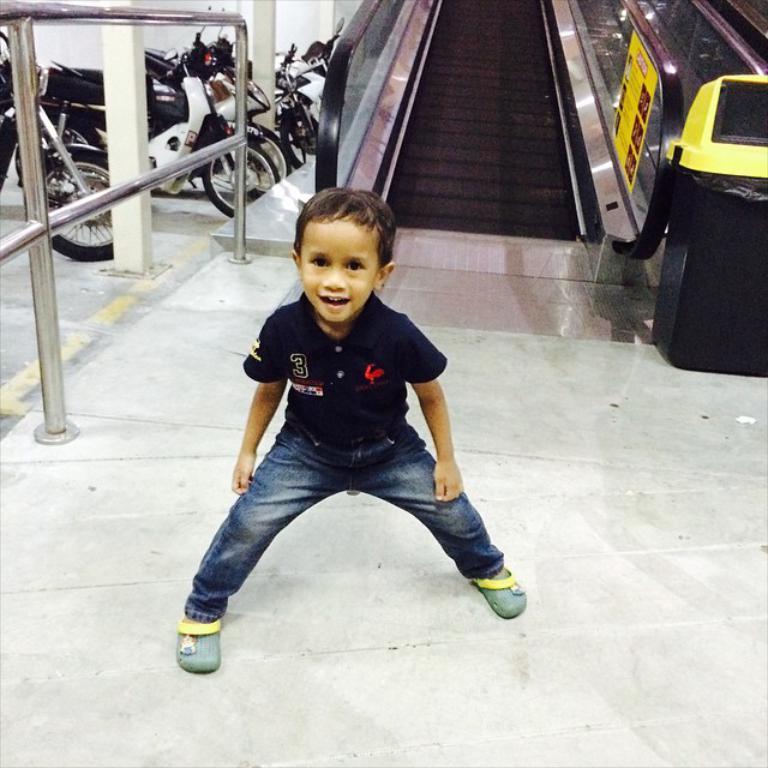Describe this image in one or two sentences. In this image we can see a kid wearing black color T-shirt blue color jeans standing and in the background of the image there is escalator, some vehicles parked and fencing. 